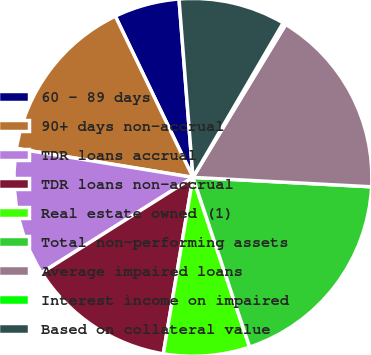Convert chart to OTSL. <chart><loc_0><loc_0><loc_500><loc_500><pie_chart><fcel>60 - 89 days<fcel>90+ days non-accrual<fcel>TDR loans accrual<fcel>TDR loans non-accrual<fcel>Real estate owned (1)<fcel>Total non-performing assets<fcel>Average impaired loans<fcel>Interest income on impaired<fcel>Based on collateral value<nl><fcel>5.9%<fcel>15.28%<fcel>11.53%<fcel>13.4%<fcel>7.78%<fcel>19.03%<fcel>17.16%<fcel>0.27%<fcel>9.65%<nl></chart> 